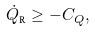Convert formula to latex. <formula><loc_0><loc_0><loc_500><loc_500>\dot { Q } _ { \text {R} } \geq - C _ { Q } ,</formula> 